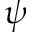Convert formula to latex. <formula><loc_0><loc_0><loc_500><loc_500>\psi</formula> 